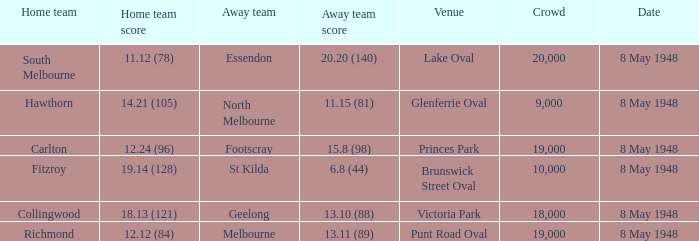How many spectators were at the game when the away team scored 15.8 (98)? 19000.0. 